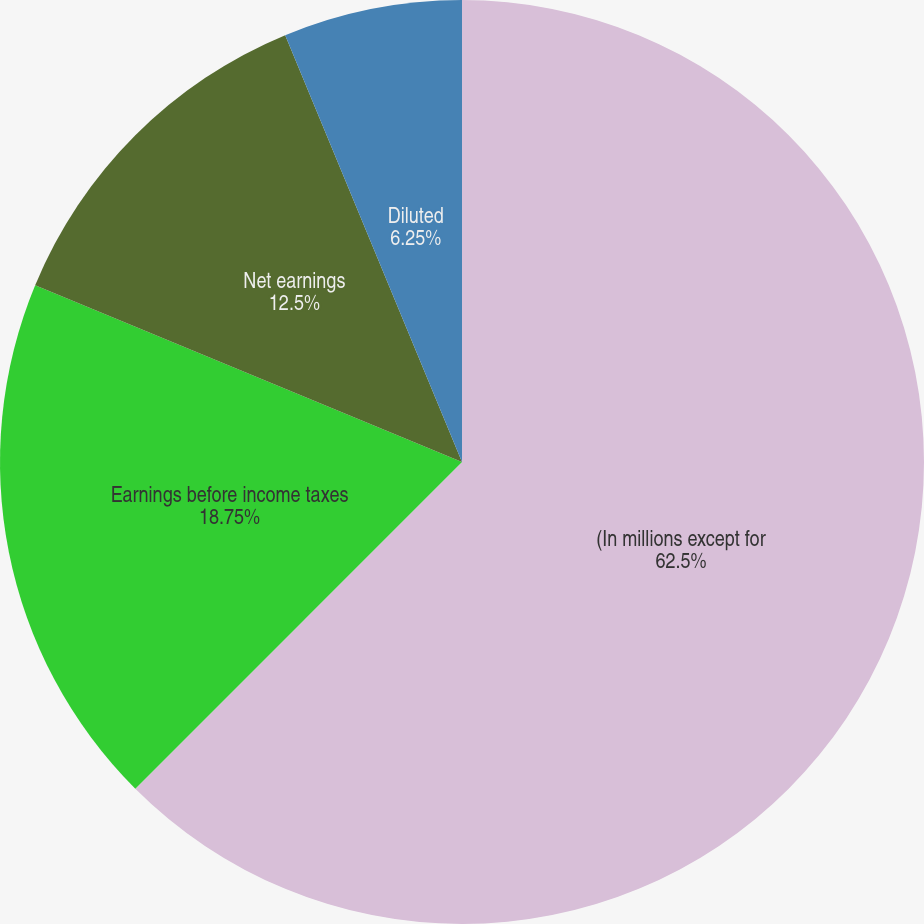<chart> <loc_0><loc_0><loc_500><loc_500><pie_chart><fcel>(In millions except for<fcel>Earnings before income taxes<fcel>Net earnings<fcel>Basic<fcel>Diluted<nl><fcel>62.5%<fcel>18.75%<fcel>12.5%<fcel>0.0%<fcel>6.25%<nl></chart> 